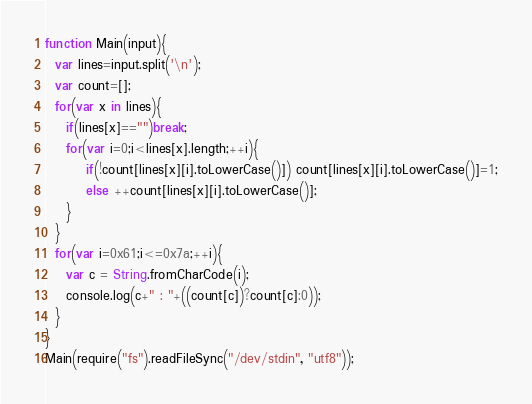Convert code to text. <code><loc_0><loc_0><loc_500><loc_500><_JavaScript_>function Main(input){
  var lines=input.split('\n');
  var count=[];
  for(var x in lines){
    if(lines[x]=="")break;
    for(var i=0;i<lines[x].length;++i){
    	if(!count[lines[x][i].toLowerCase()]) count[lines[x][i].toLowerCase()]=1;
    	else ++count[lines[x][i].toLowerCase()];
    }
  }
  for(var i=0x61;i<=0x7a;++i){
  	var c = String.fromCharCode(i);
  	console.log(c+" : "+((count[c])?count[c]:0));
  }
}
Main(require("fs").readFileSync("/dev/stdin", "utf8"));</code> 